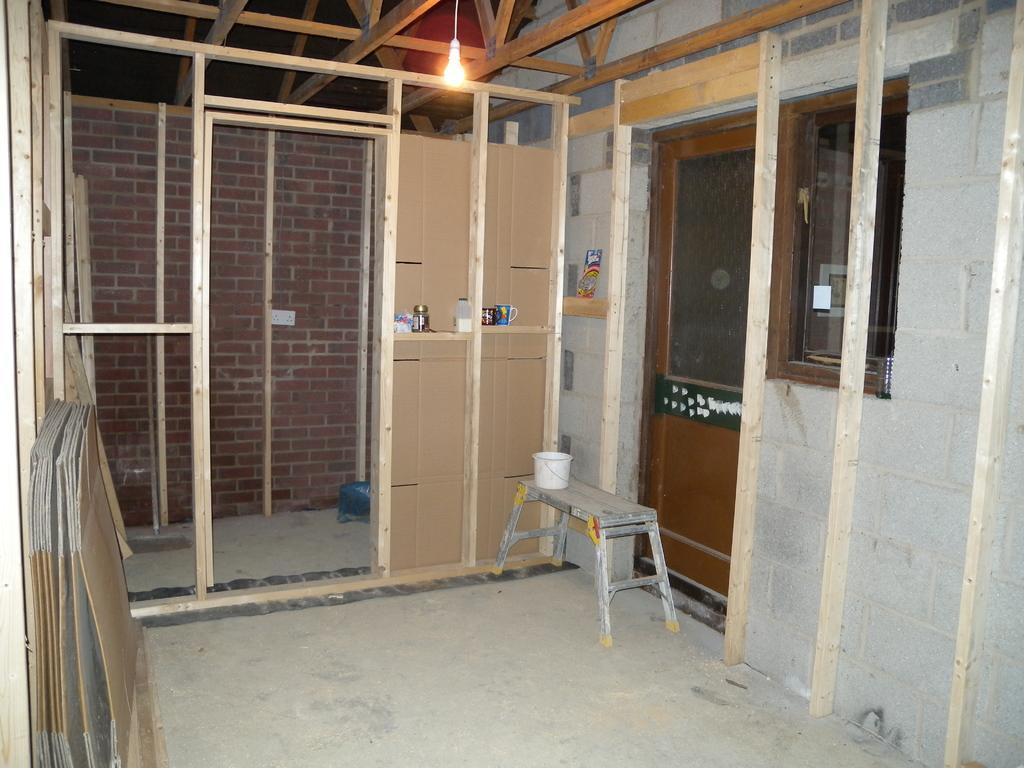Could you give a brief overview of what you see in this image? In this image I can see inside view of a building and I can see this room is under construction. On the right side of the image I can see a door, a window, a table and on it I can see a white colour bucket. On the left side of the image I can see few cardboard papers. In the background I can see few more cardboard papers, two mugs, a jar and few other things. On the top side of the image I can see a light. 